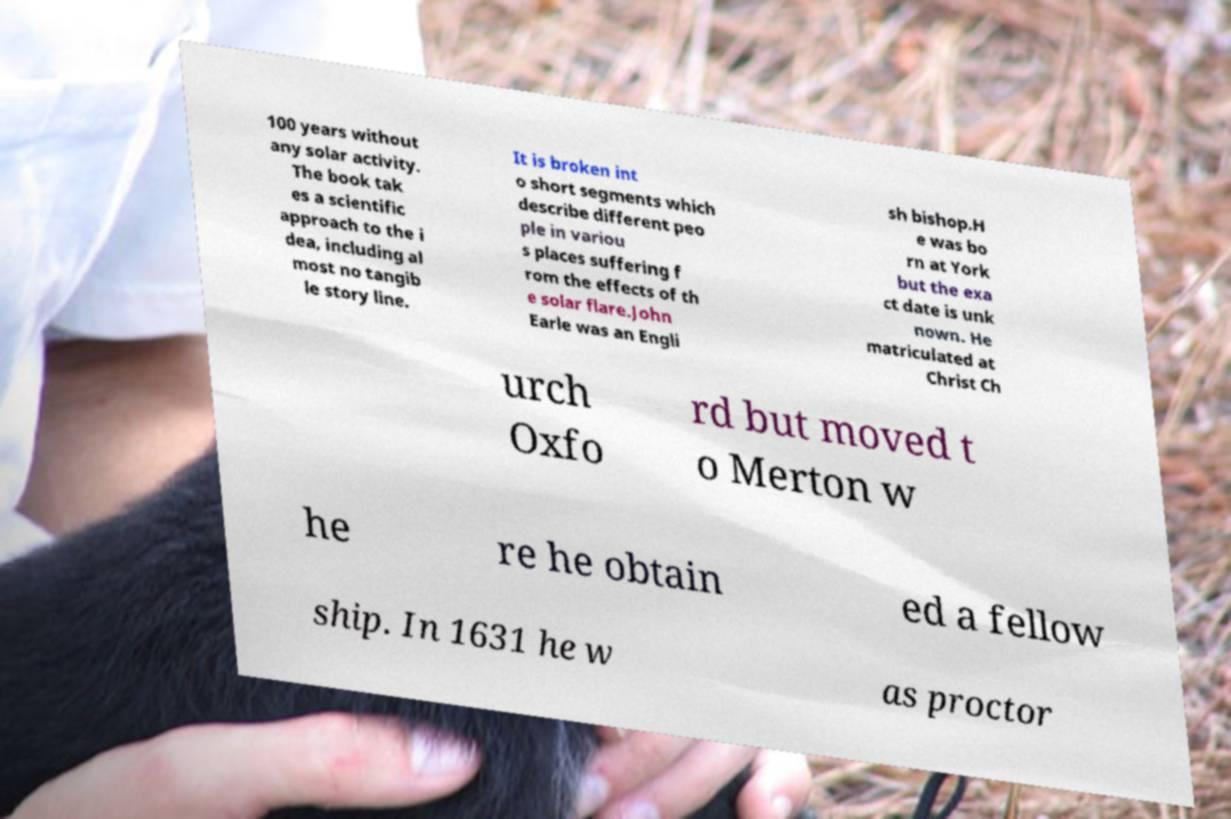Please identify and transcribe the text found in this image. 100 years without any solar activity. The book tak es a scientific approach to the i dea, including al most no tangib le story line. It is broken int o short segments which describe different peo ple in variou s places suffering f rom the effects of th e solar flare.John Earle was an Engli sh bishop.H e was bo rn at York but the exa ct date is unk nown. He matriculated at Christ Ch urch Oxfo rd but moved t o Merton w he re he obtain ed a fellow ship. In 1631 he w as proctor 